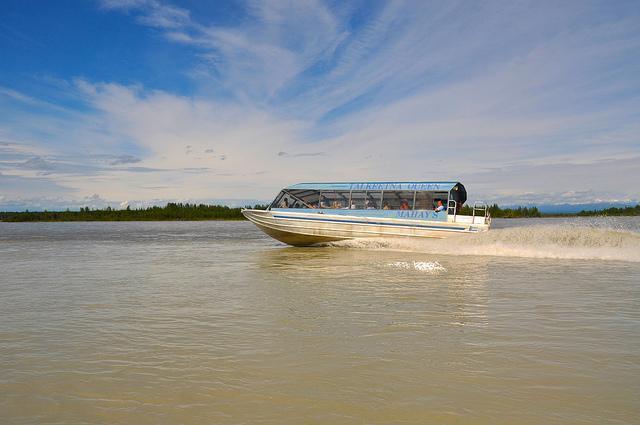What is this watercraft's purpose?
Select the accurate answer and provide explanation: 'Answer: answer
Rationale: rationale.'
Options: Research, excursions, fishing, hunting. Answer: excursions.
Rationale: The boat takes people on fun adventures for vacations. 